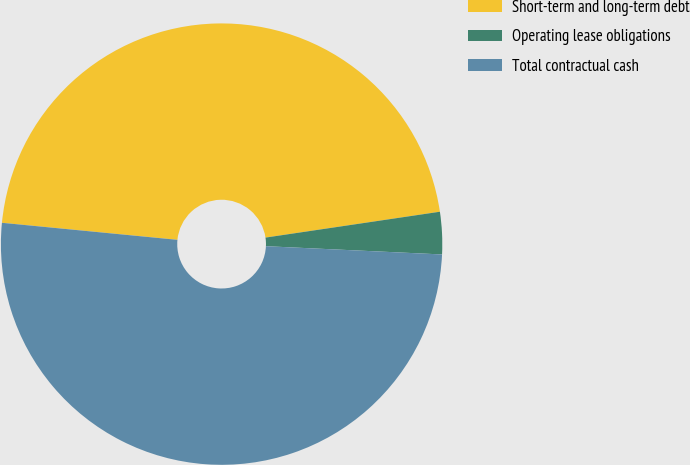<chart> <loc_0><loc_0><loc_500><loc_500><pie_chart><fcel>Short-term and long-term debt<fcel>Operating lease obligations<fcel>Total contractual cash<nl><fcel>46.11%<fcel>3.09%<fcel>50.79%<nl></chart> 